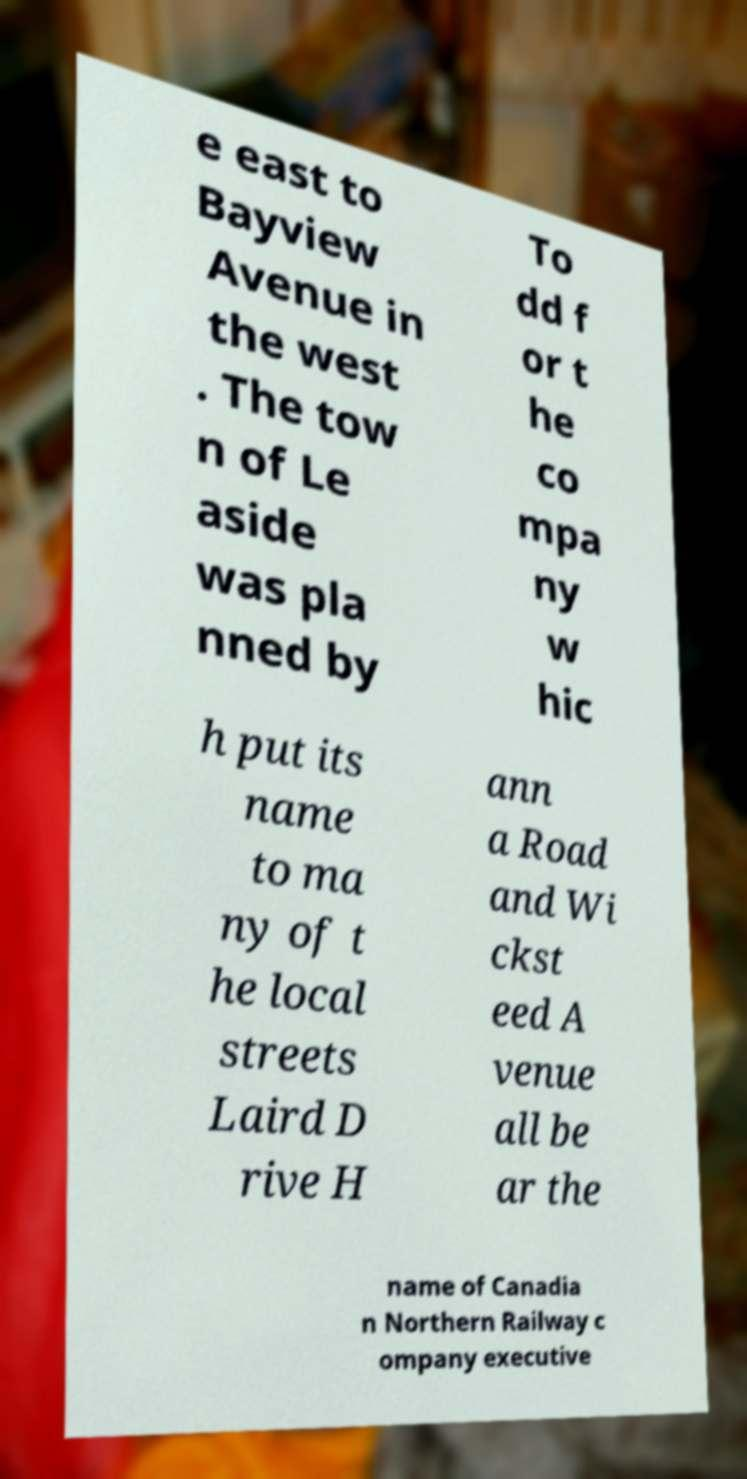Please read and relay the text visible in this image. What does it say? e east to Bayview Avenue in the west . The tow n of Le aside was pla nned by To dd f or t he co mpa ny w hic h put its name to ma ny of t he local streets Laird D rive H ann a Road and Wi ckst eed A venue all be ar the name of Canadia n Northern Railway c ompany executive 